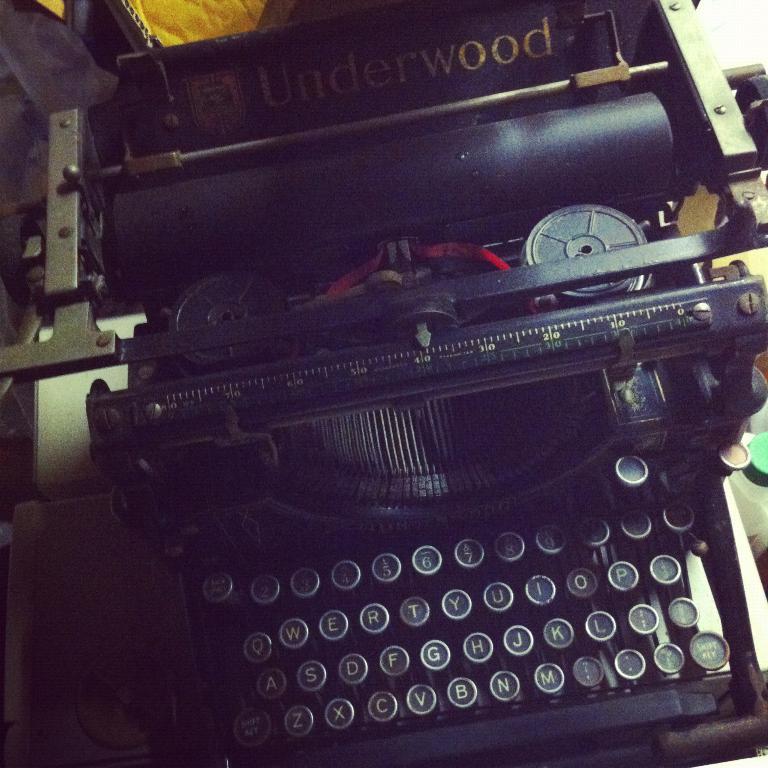What is the name of this precursor to computer technology?
Your answer should be very brief. Answering does not require reading text in the image. What company made this typewriter?
Keep it short and to the point. Underwood. 